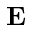Convert formula to latex. <formula><loc_0><loc_0><loc_500><loc_500>E</formula> 